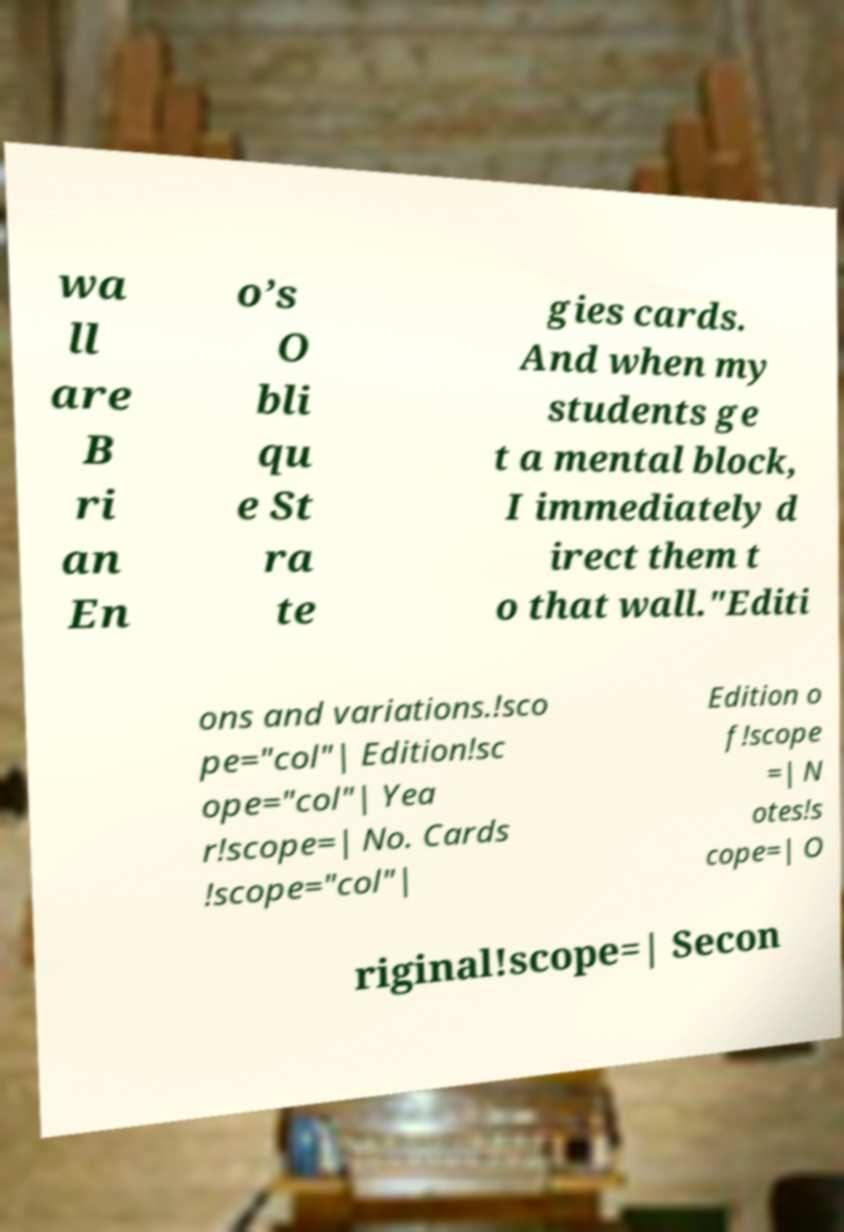Can you read and provide the text displayed in the image?This photo seems to have some interesting text. Can you extract and type it out for me? wa ll are B ri an En o’s O bli qu e St ra te gies cards. And when my students ge t a mental block, I immediately d irect them t o that wall."Editi ons and variations.!sco pe="col"| Edition!sc ope="col"| Yea r!scope=| No. Cards !scope="col"| Edition o f!scope =| N otes!s cope=| O riginal!scope=| Secon 